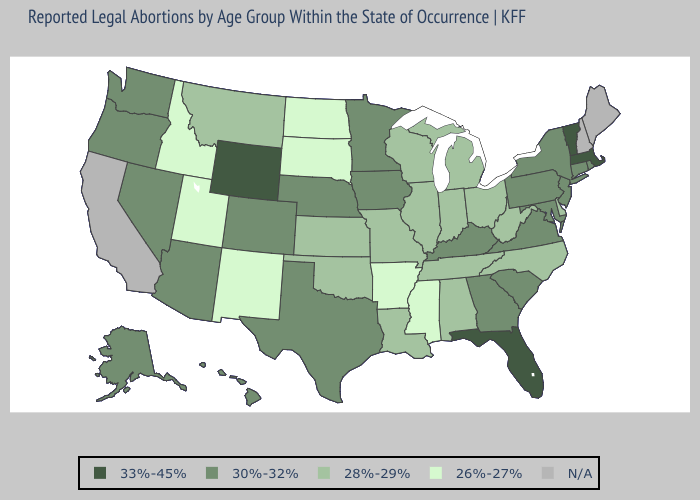Name the states that have a value in the range N/A?
Answer briefly. California, Maine, New Hampshire. Does Idaho have the highest value in the USA?
Write a very short answer. No. What is the value of Kansas?
Quick response, please. 28%-29%. What is the lowest value in the West?
Concise answer only. 26%-27%. Name the states that have a value in the range 28%-29%?
Answer briefly. Alabama, Delaware, Illinois, Indiana, Kansas, Louisiana, Michigan, Missouri, Montana, North Carolina, Ohio, Oklahoma, Tennessee, West Virginia, Wisconsin. Among the states that border Washington , does Oregon have the highest value?
Answer briefly. Yes. What is the value of Washington?
Keep it brief. 30%-32%. What is the value of Indiana?
Quick response, please. 28%-29%. What is the highest value in states that border Montana?
Quick response, please. 33%-45%. Name the states that have a value in the range 33%-45%?
Concise answer only. Florida, Massachusetts, Vermont, Wyoming. What is the value of Virginia?
Concise answer only. 30%-32%. What is the highest value in the USA?
Give a very brief answer. 33%-45%. Does the map have missing data?
Write a very short answer. Yes. 